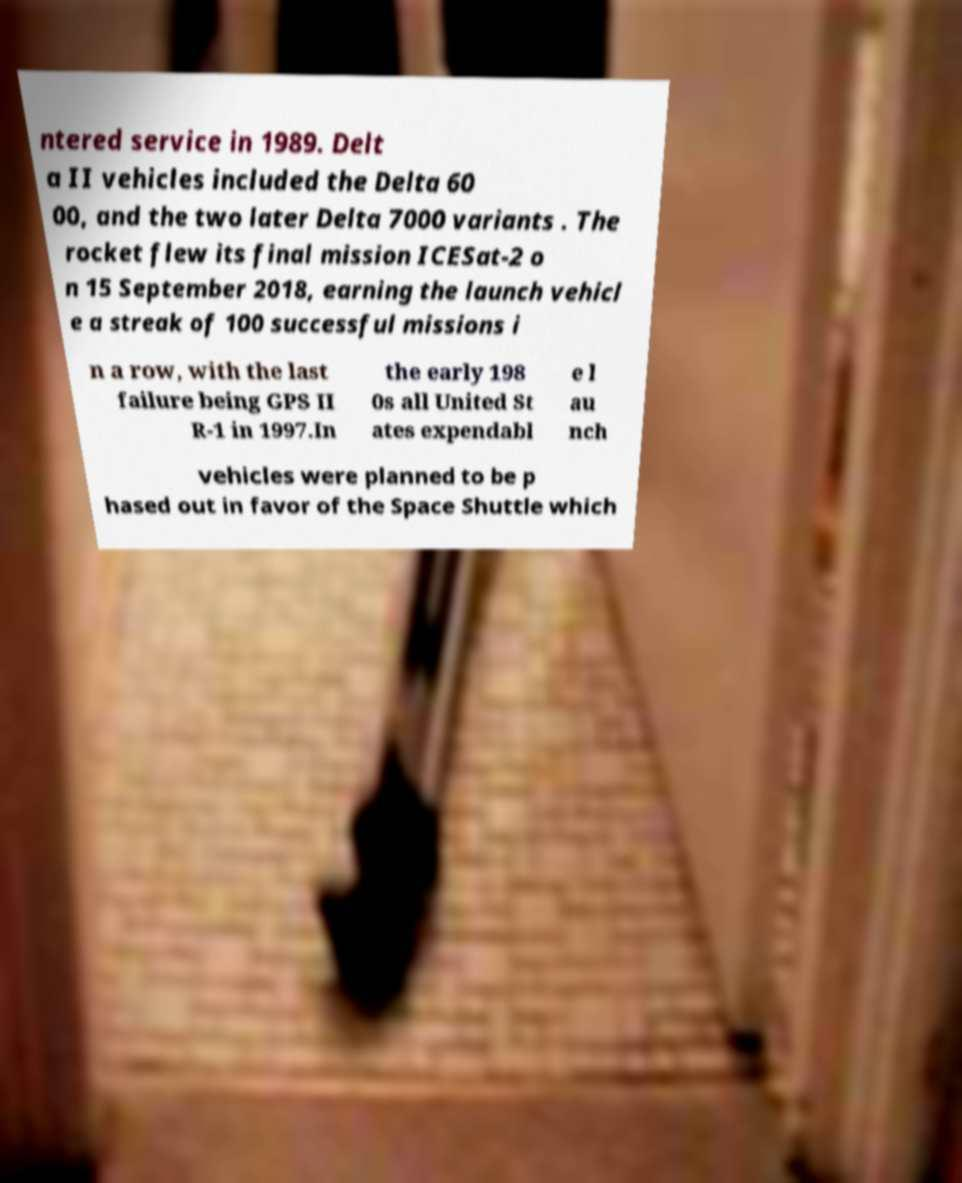Could you assist in decoding the text presented in this image and type it out clearly? ntered service in 1989. Delt a II vehicles included the Delta 60 00, and the two later Delta 7000 variants . The rocket flew its final mission ICESat-2 o n 15 September 2018, earning the launch vehicl e a streak of 100 successful missions i n a row, with the last failure being GPS II R-1 in 1997.In the early 198 0s all United St ates expendabl e l au nch vehicles were planned to be p hased out in favor of the Space Shuttle which 